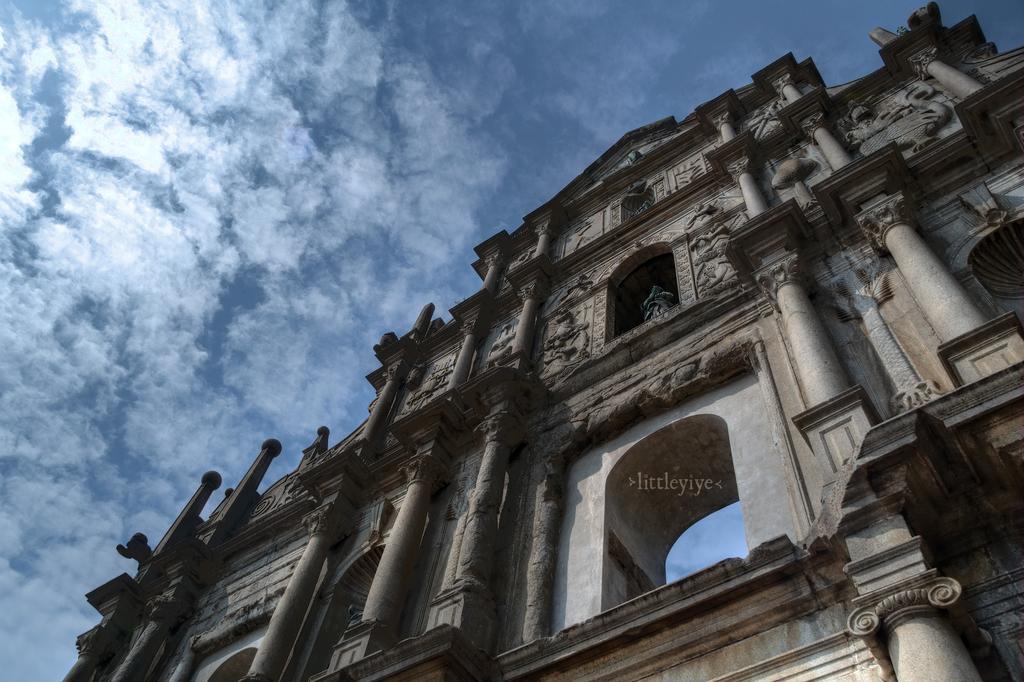Please provide a concise description of this image. In this image there is one building and sculptures, at the top there is sky. 